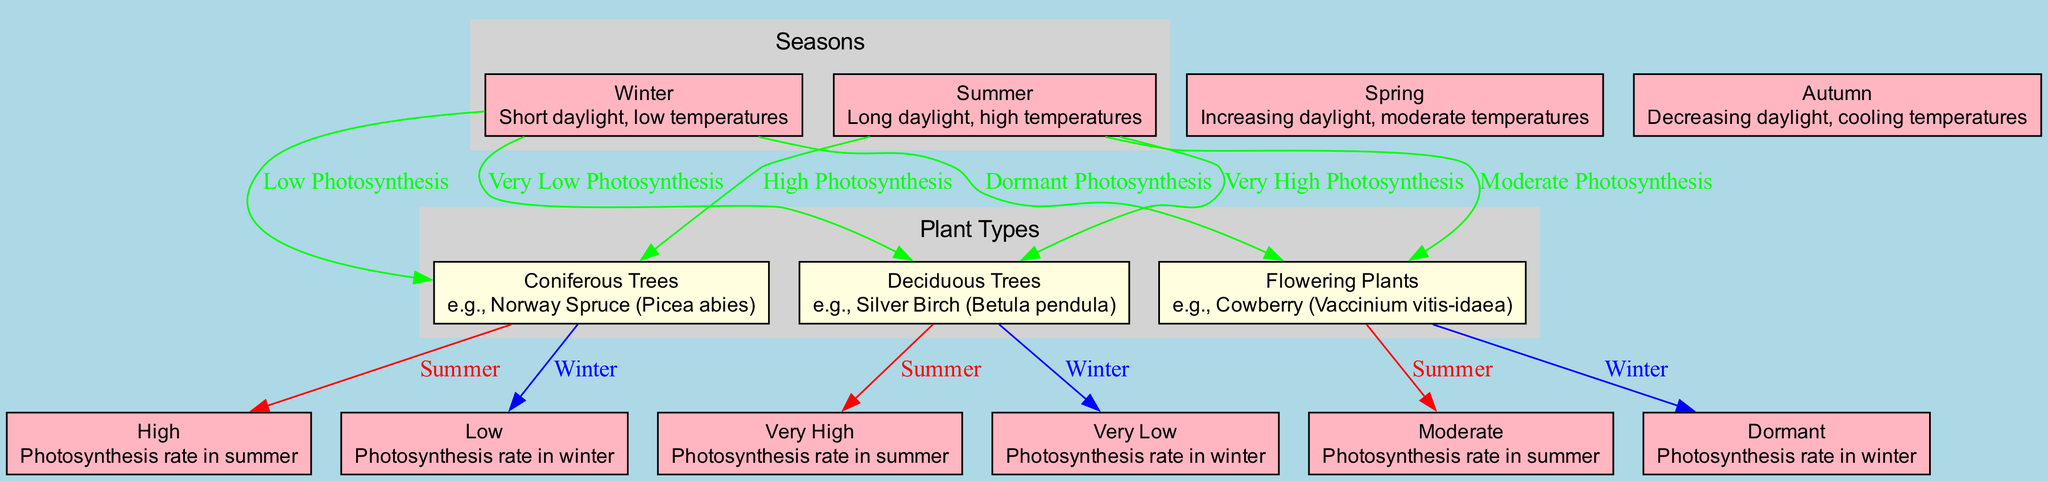What is the photosynthesis rate of flowering plants in winter? According to the diagram, the photosynthesis rate for flowering plants in winter is categorized as "Dormant".
Answer: Dormant Which plant type has a very high photosynthesis rate in summer? The diagram shows that deciduous trees have a very high photosynthesis rate in summer.
Answer: Deciduous Trees How many edges are there connecting winter to different plant types? There are three edges connecting winter to coniferous trees, deciduous trees, and flowering plants, as indicated in the diagram.
Answer: Three What is the color of edges representing winter photosynthesis rates? The edges representing winter photosynthesis rates are colored blue, which is clearly denoted in the diagram.
Answer: Blue Which plant has a moderate photosynthesis rate in summer? The diagram indicates that flowering plants have a moderate photosynthesis rate during summer.
Answer: Flowering Plants What seasonal changes do coniferous trees experience in photosynthesis from winter to summer? The diagram clearly illustrates that coniferous trees experience a change from low photosynthesis in winter to high photosynthesis in summer, reflecting a significant increase.
Answer: Low to High What type of plant has a lower photosynthesis rate in winter: coniferous trees or deciduous trees? By contrasting the two, the diagram shows coniferous trees have low while deciduous trees have very low photosynthesis in winter, indicating coniferous trees have the higher rate.
Answer: Coniferous Trees How many seasons are represented in the diagram? The diagram represents four seasons: Winter, Spring, Summer, and Autumn, which can be counted directly from the nodes.
Answer: Four Which plant type exhibits high photosynthesis in summer? The diagram explains that both coniferous trees and flowering plants exhibit high or moderate photosynthesis rates in summer, but only coniferous trees are classified as high.
Answer: Coniferous Trees 